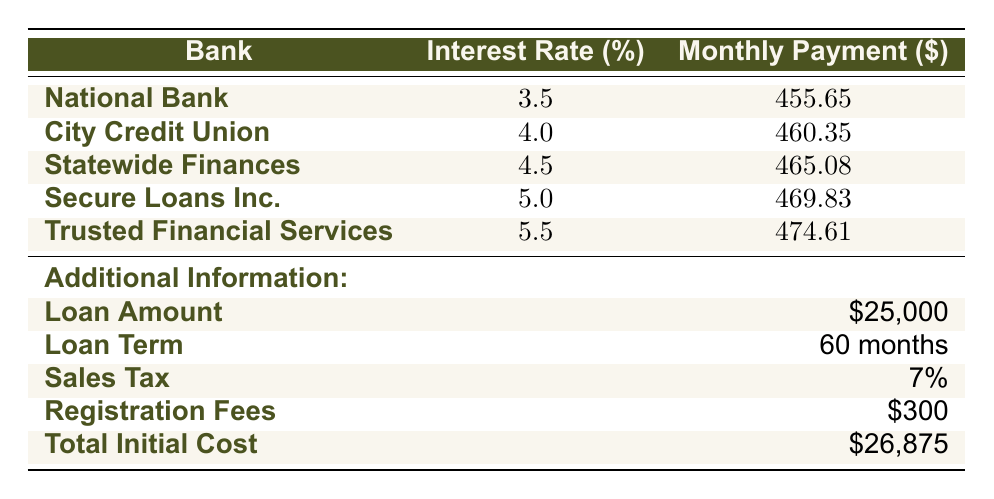What is the monthly payment for the loan from National Bank? The table shows that the monthly payment for the loan from National Bank is listed in the corresponding row under the 'Monthly Payment' column. For National Bank, the amount is 455.65.
Answer: 455.65 Which bank offers the highest interest rate and what is that rate? Looking at the 'Interest Rate' column, we find the highest value is 5.5, which corresponds to Trusted Financial Services. Thus, the highest interest rate is 5.5.
Answer: 5.5 What is the total initial cost of the car loan including all additional costs? The 'Total Initial Cost' row indicates that the overall amount required when initially obtaining the loan, including sales tax and registration fees, is 26,875.
Answer: 26,875 If National Bank’s monthly payment is compared to that of Secure Loans Inc., how much more would a borrower pay at Secure Loans Inc.? The monthly payment for Secure Loans Inc. is 469.83 and for National Bank it is 455.65. The difference is calculated as 469.83 - 455.65 = 14.18. Therefore, a borrower would pay an additional 14.18 monthly at Secure Loans Inc.
Answer: 14.18 Is the sales tax percentage higher than 5% in this loan structure? The sales tax listed in the table is 7%, which is indeed greater than 5%. Therefore, the answer is yes.
Answer: Yes What is the average monthly payment across all banks listed? To find the average, we need to sum the monthly payments: 455.65 + 460.35 + 465.08 + 469.83 + 474.61 = 2285.52. Then divide by the number of banks, which is 5: 2285.52 / 5 = 457.10. The average monthly payment is 457.10.
Answer: 457.10 Does City Credit Union have a lower monthly payment than Statewide Finances? The monthly payment for City Credit Union is 460.35, while Statewide Finances charges 465.08. Since 460.35 < 465.08, City Credit Union does have a lower monthly payment. Therefore, the answer is yes.
Answer: Yes What would be the total cost paid after 60 months if one chooses Secure Loans Inc.? The monthly payment at Secure Loans Inc. is 469.83. Over 60 months, the total would be calculated as: 469.83 * 60 = 28189.80. Thus, the total cost over the loan term would be 28189.80.
Answer: 28189.80 